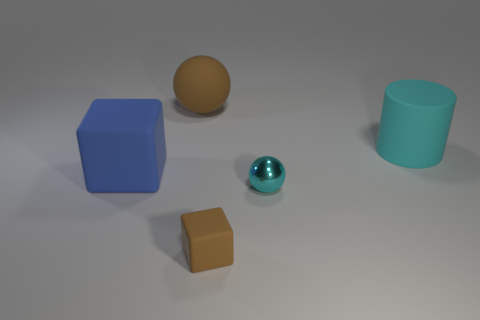Add 5 small brown things. How many objects exist? 10 Add 5 rubber cylinders. How many rubber cylinders are left? 6 Add 3 small cyan spheres. How many small cyan spheres exist? 4 Subtract all blue blocks. How many blocks are left? 1 Subtract 0 yellow cylinders. How many objects are left? 5 Subtract all balls. How many objects are left? 3 Subtract 1 blocks. How many blocks are left? 1 Subtract all brown spheres. Subtract all yellow cylinders. How many spheres are left? 1 Subtract all blue cylinders. How many red balls are left? 0 Subtract all large red metal objects. Subtract all blue blocks. How many objects are left? 4 